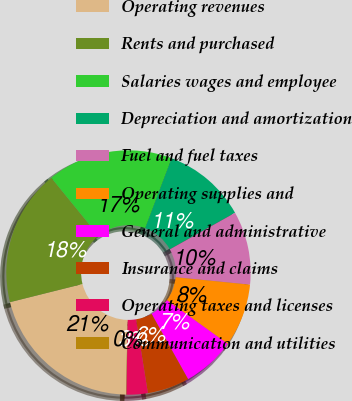Convert chart. <chart><loc_0><loc_0><loc_500><loc_500><pie_chart><fcel>Operating revenues<fcel>Rents and purchased<fcel>Salaries wages and employee<fcel>Depreciation and amortization<fcel>Fuel and fuel taxes<fcel>Operating supplies and<fcel>General and administrative<fcel>Insurance and claims<fcel>Operating taxes and licenses<fcel>Communication and utilities<nl><fcel>20.79%<fcel>18.02%<fcel>16.64%<fcel>11.11%<fcel>9.72%<fcel>8.34%<fcel>6.96%<fcel>5.57%<fcel>2.81%<fcel>0.04%<nl></chart> 